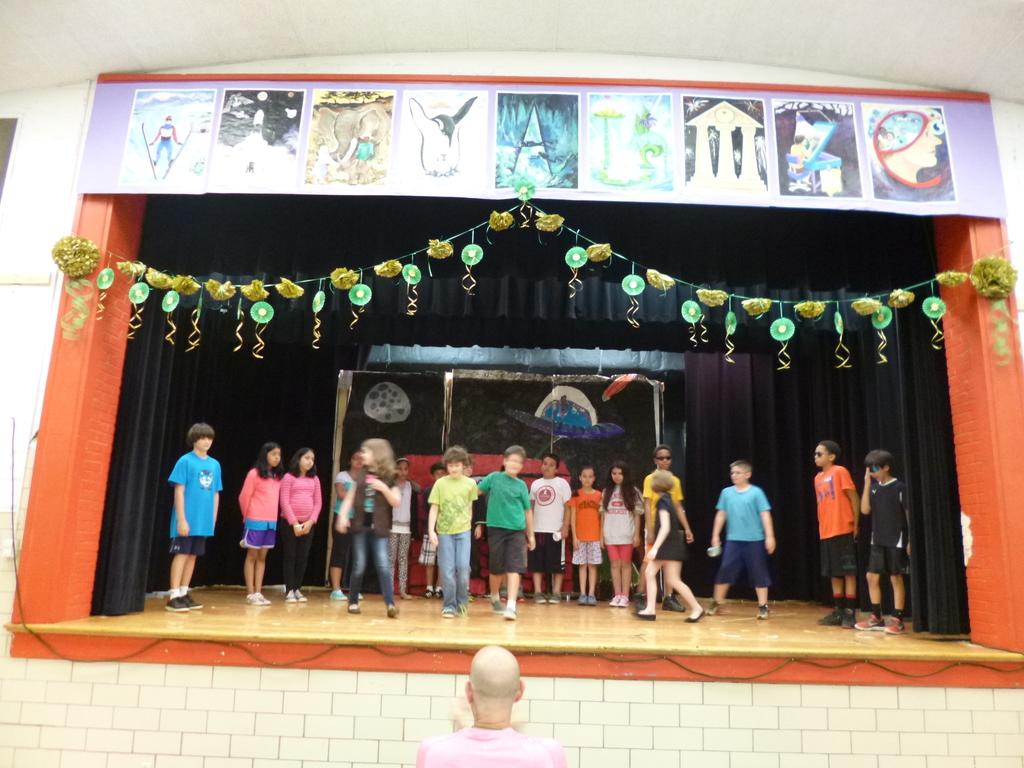Where is the person located in the image? The person is at the bottom side of the image. What are the people on the stage doing? The people on the stage are standing. What can be seen in the center of the image? There are posters and decorative pieces in the center of the image. What type of jelly is being served to the audience in the image? There is no mention of jelly or any food being served in the image. How many songs are being performed by the people on the stage in the image? The image does not provide information about the number of songs being performed. 